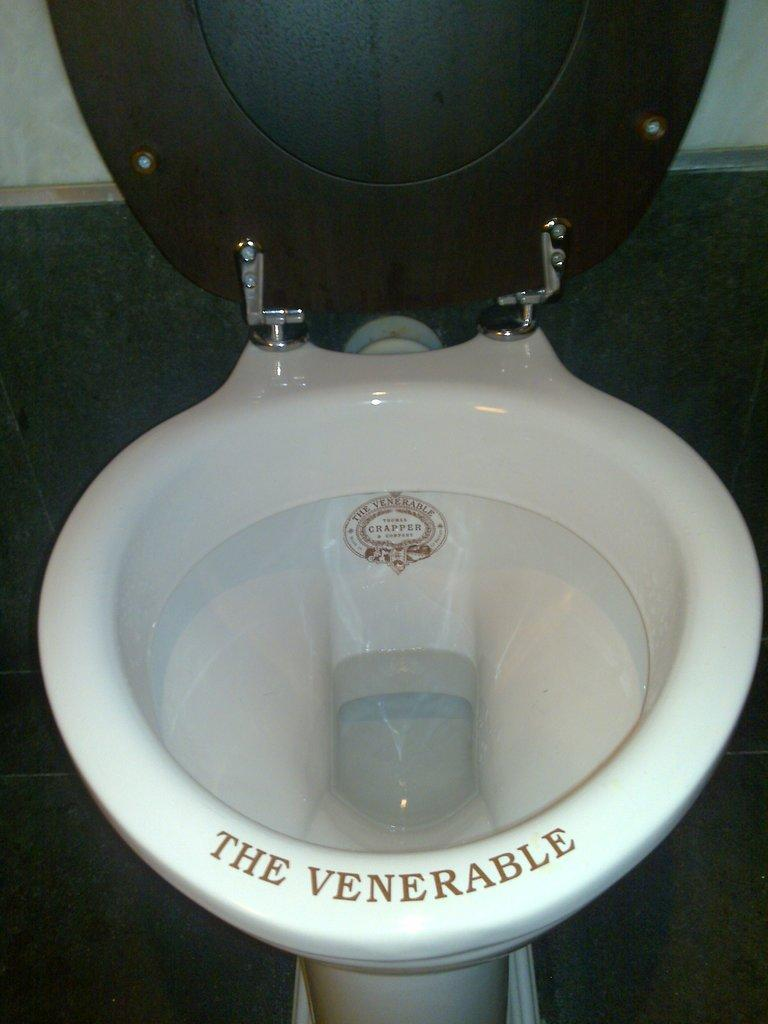<image>
Give a short and clear explanation of the subsequent image. A white toilet bears the name "The Venerable." 